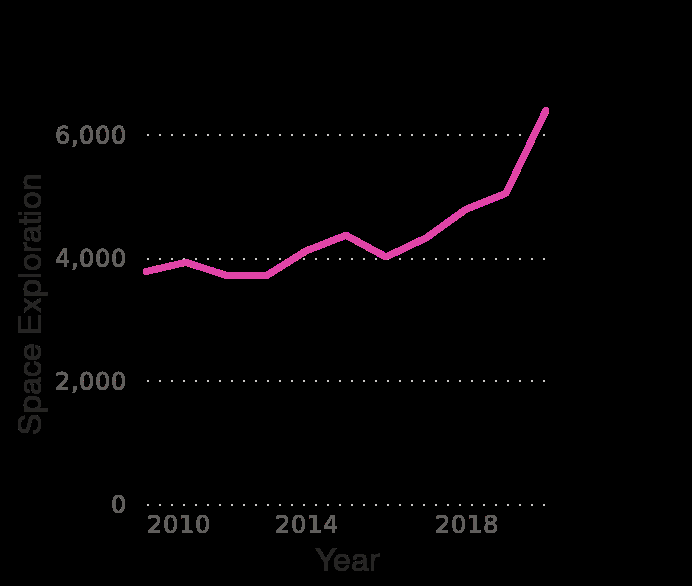<image>
What variable is represented on the x-axis? The variable represented on the x-axis is the Year. Describe the following image in detail Breakdown of NASA 's budget and how it was distributed from 2010 to 2020 (in million U.S dollars) is a line chart. Along the x-axis, Year is defined using a linear scale of range 2010 to 2018. A linear scale of range 0 to 6,000 can be found on the y-axis, labeled Space Exploration. What is the range of the x-axis in the line chart?  The range of the x-axis in the line chart is from 2010 to 2018. 